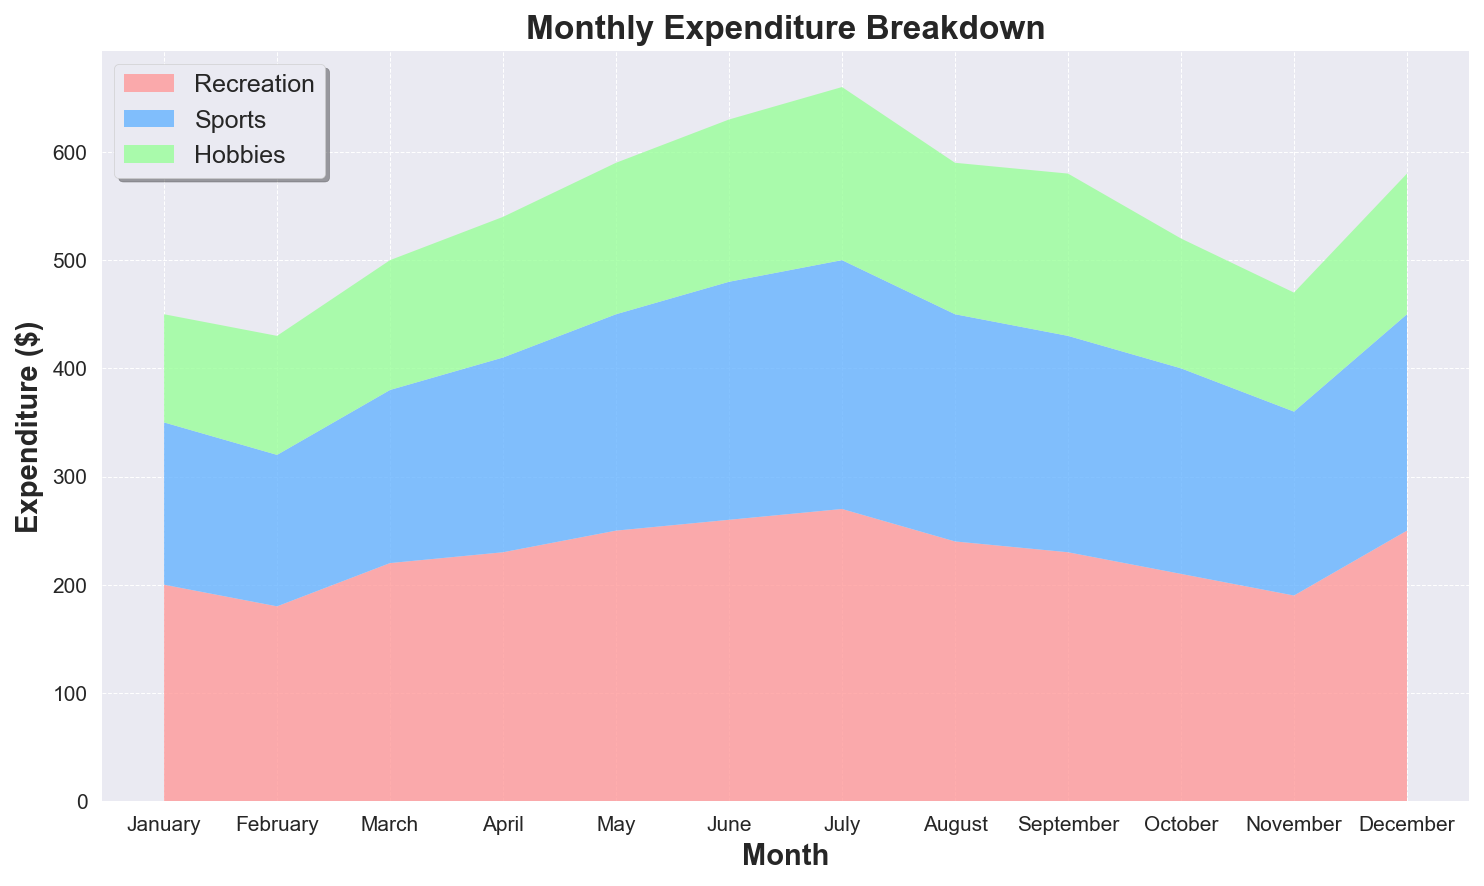What month had the highest total expenditure? Looking at the chart, identify the month with the highest area covered. The month of July shows the largest combined area, indicating the highest total expenditure.
Answer: July In which month did the expenditure on sports peak? Focus on the blue area representing sports. The highest point of the blue area is seen in July.
Answer: July What is the difference in total expenditure between May and June? From the chart, note the total expenditure for May and June, which are 590 and 630, respectively. Calculate the difference: 630 - 590 = 40
Answer: 40 Which category consistently had the lowest expenditure across all months? Compare the areas of Recreation (red), Sports (blue), and Hobbies (green) over all months. The green area (Hobbies) is mostly the smallest throughout the months.
Answer: Hobbies How did the total expenditure change from January to February? Compare the total height combining all areas from January (450) to February (430). The total decrease is 450 - 430 = 20
Answer: Decreased by 20 What are the three months with the highest expenditure on recreation? Locate the red areas throughout the chart. The highest points for Recreation (red) are in July (270), June (260), and May (250).
Answer: July, June, May In which month did both sports and hobbies expenditure reach a local minimum simultaneously? Look for the blue (sports) and green (hobbies) areas where both are near their lowest points together. Both are at a local minimum in February.
Answer: February What was the increase in total expenditure from November to December? Note the total expenditures: November (470) and December (580). Calculate the increase: 580 - 470 = 110
Answer: 110 How does the recreational expenditure in March compare to April? Compare the red area heights for March (220) and April (230). April’s recreational expenditure is slightly higher than March’s.
Answer: April is higher What's the average monthly expenditure on hobbies? Sum up the green areas' values over all months (100 + 110 + 120 + 130 + 140 + 150 + 160 + 140 + 150 + 120 + 110 + 130 = 1560) and divide by 12 (months): 1560 / 12 = 130
Answer: 130 